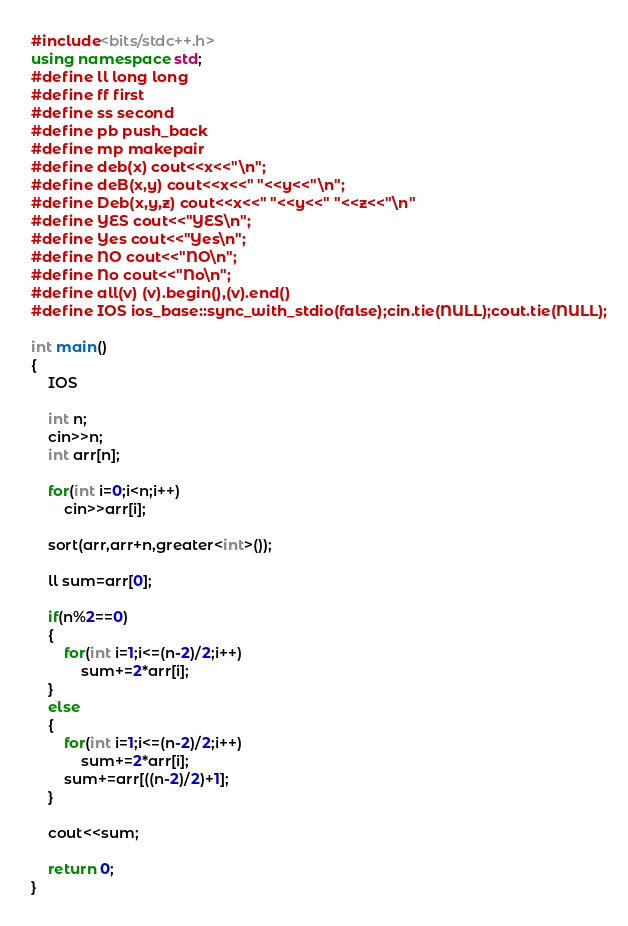<code> <loc_0><loc_0><loc_500><loc_500><_C++_>#include<bits/stdc++.h>
using namespace std;
#define ll long long
#define ff first
#define ss second
#define pb push_back
#define mp makepair
#define deb(x) cout<<x<<"\n";
#define deB(x,y) cout<<x<<" "<<y<<"\n";
#define Deb(x,y,z) cout<<x<<" "<<y<<" "<<z<<"\n"
#define YES cout<<"YES\n";
#define Yes cout<<"Yes\n";
#define NO cout<<"NO\n";
#define No cout<<"No\n";
#define all(v) (v).begin(),(v).end()
#define IOS ios_base::sync_with_stdio(false);cin.tie(NULL);cout.tie(NULL);

int main()
{
    IOS

    int n;
    cin>>n;
    int arr[n];

    for(int i=0;i<n;i++)
        cin>>arr[i];

    sort(arr,arr+n,greater<int>());

    ll sum=arr[0];

    if(n%2==0)
    {
        for(int i=1;i<=(n-2)/2;i++)
            sum+=2*arr[i];
    }
    else
    {
        for(int i=1;i<=(n-2)/2;i++)
            sum+=2*arr[i];
        sum+=arr[((n-2)/2)+1];
    }

    cout<<sum;

    return 0;
}
</code> 